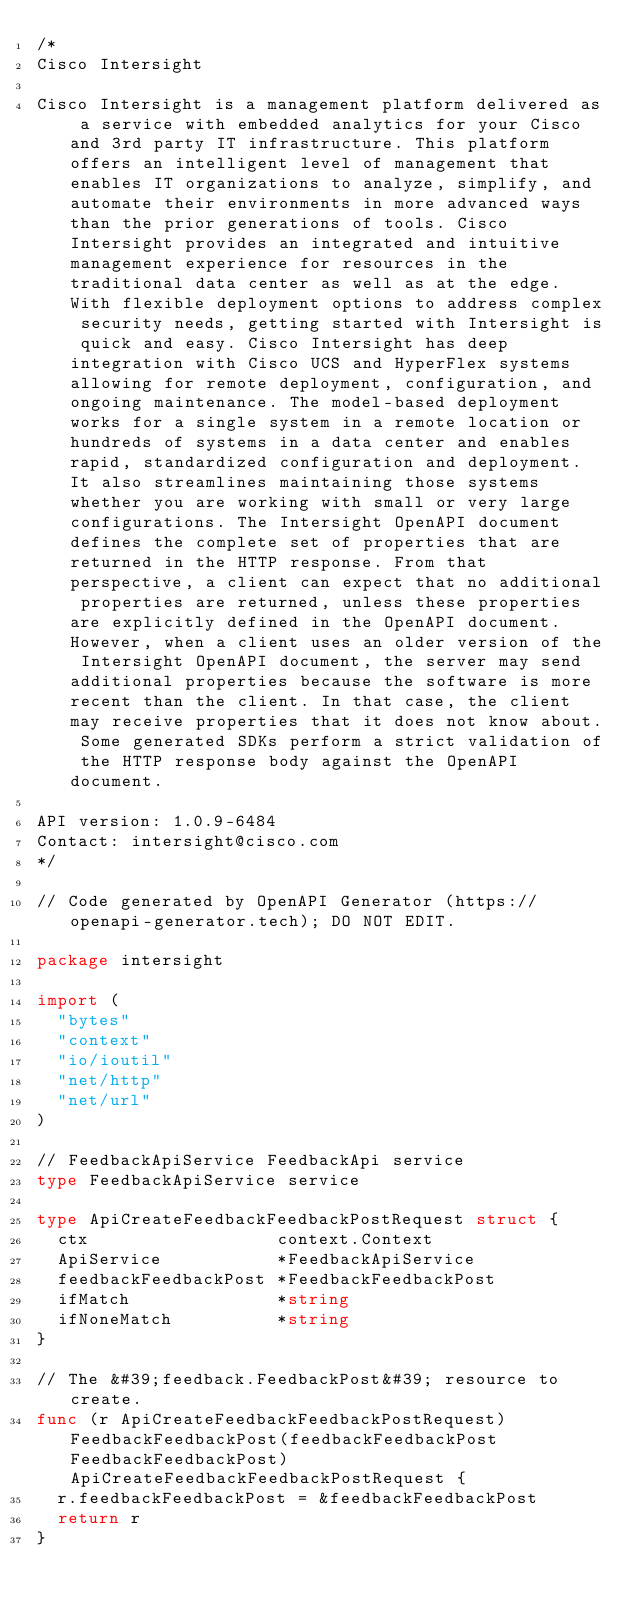<code> <loc_0><loc_0><loc_500><loc_500><_Go_>/*
Cisco Intersight

Cisco Intersight is a management platform delivered as a service with embedded analytics for your Cisco and 3rd party IT infrastructure. This platform offers an intelligent level of management that enables IT organizations to analyze, simplify, and automate their environments in more advanced ways than the prior generations of tools. Cisco Intersight provides an integrated and intuitive management experience for resources in the traditional data center as well as at the edge. With flexible deployment options to address complex security needs, getting started with Intersight is quick and easy. Cisco Intersight has deep integration with Cisco UCS and HyperFlex systems allowing for remote deployment, configuration, and ongoing maintenance. The model-based deployment works for a single system in a remote location or hundreds of systems in a data center and enables rapid, standardized configuration and deployment. It also streamlines maintaining those systems whether you are working with small or very large configurations. The Intersight OpenAPI document defines the complete set of properties that are returned in the HTTP response. From that perspective, a client can expect that no additional properties are returned, unless these properties are explicitly defined in the OpenAPI document. However, when a client uses an older version of the Intersight OpenAPI document, the server may send additional properties because the software is more recent than the client. In that case, the client may receive properties that it does not know about. Some generated SDKs perform a strict validation of the HTTP response body against the OpenAPI document.

API version: 1.0.9-6484
Contact: intersight@cisco.com
*/

// Code generated by OpenAPI Generator (https://openapi-generator.tech); DO NOT EDIT.

package intersight

import (
	"bytes"
	"context"
	"io/ioutil"
	"net/http"
	"net/url"
)

// FeedbackApiService FeedbackApi service
type FeedbackApiService service

type ApiCreateFeedbackFeedbackPostRequest struct {
	ctx                  context.Context
	ApiService           *FeedbackApiService
	feedbackFeedbackPost *FeedbackFeedbackPost
	ifMatch              *string
	ifNoneMatch          *string
}

// The &#39;feedback.FeedbackPost&#39; resource to create.
func (r ApiCreateFeedbackFeedbackPostRequest) FeedbackFeedbackPost(feedbackFeedbackPost FeedbackFeedbackPost) ApiCreateFeedbackFeedbackPostRequest {
	r.feedbackFeedbackPost = &feedbackFeedbackPost
	return r
}
</code> 